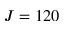Convert formula to latex. <formula><loc_0><loc_0><loc_500><loc_500>J = 1 2 0</formula> 